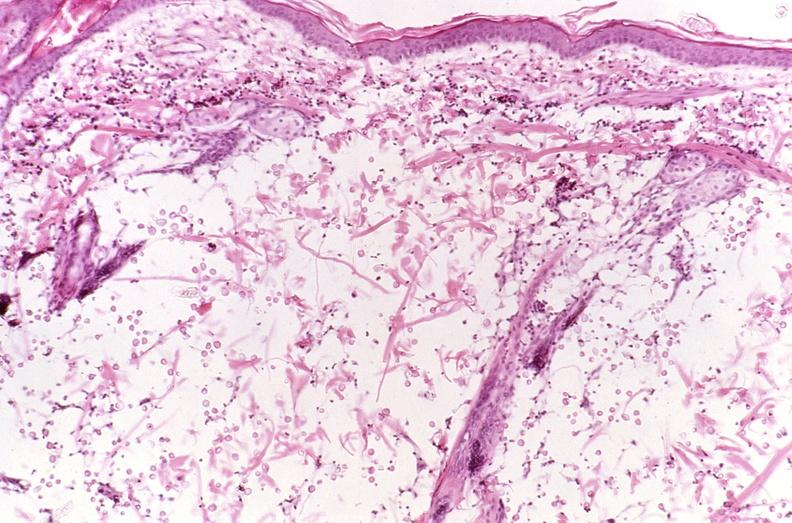where is this?
Answer the question using a single word or phrase. Skin 